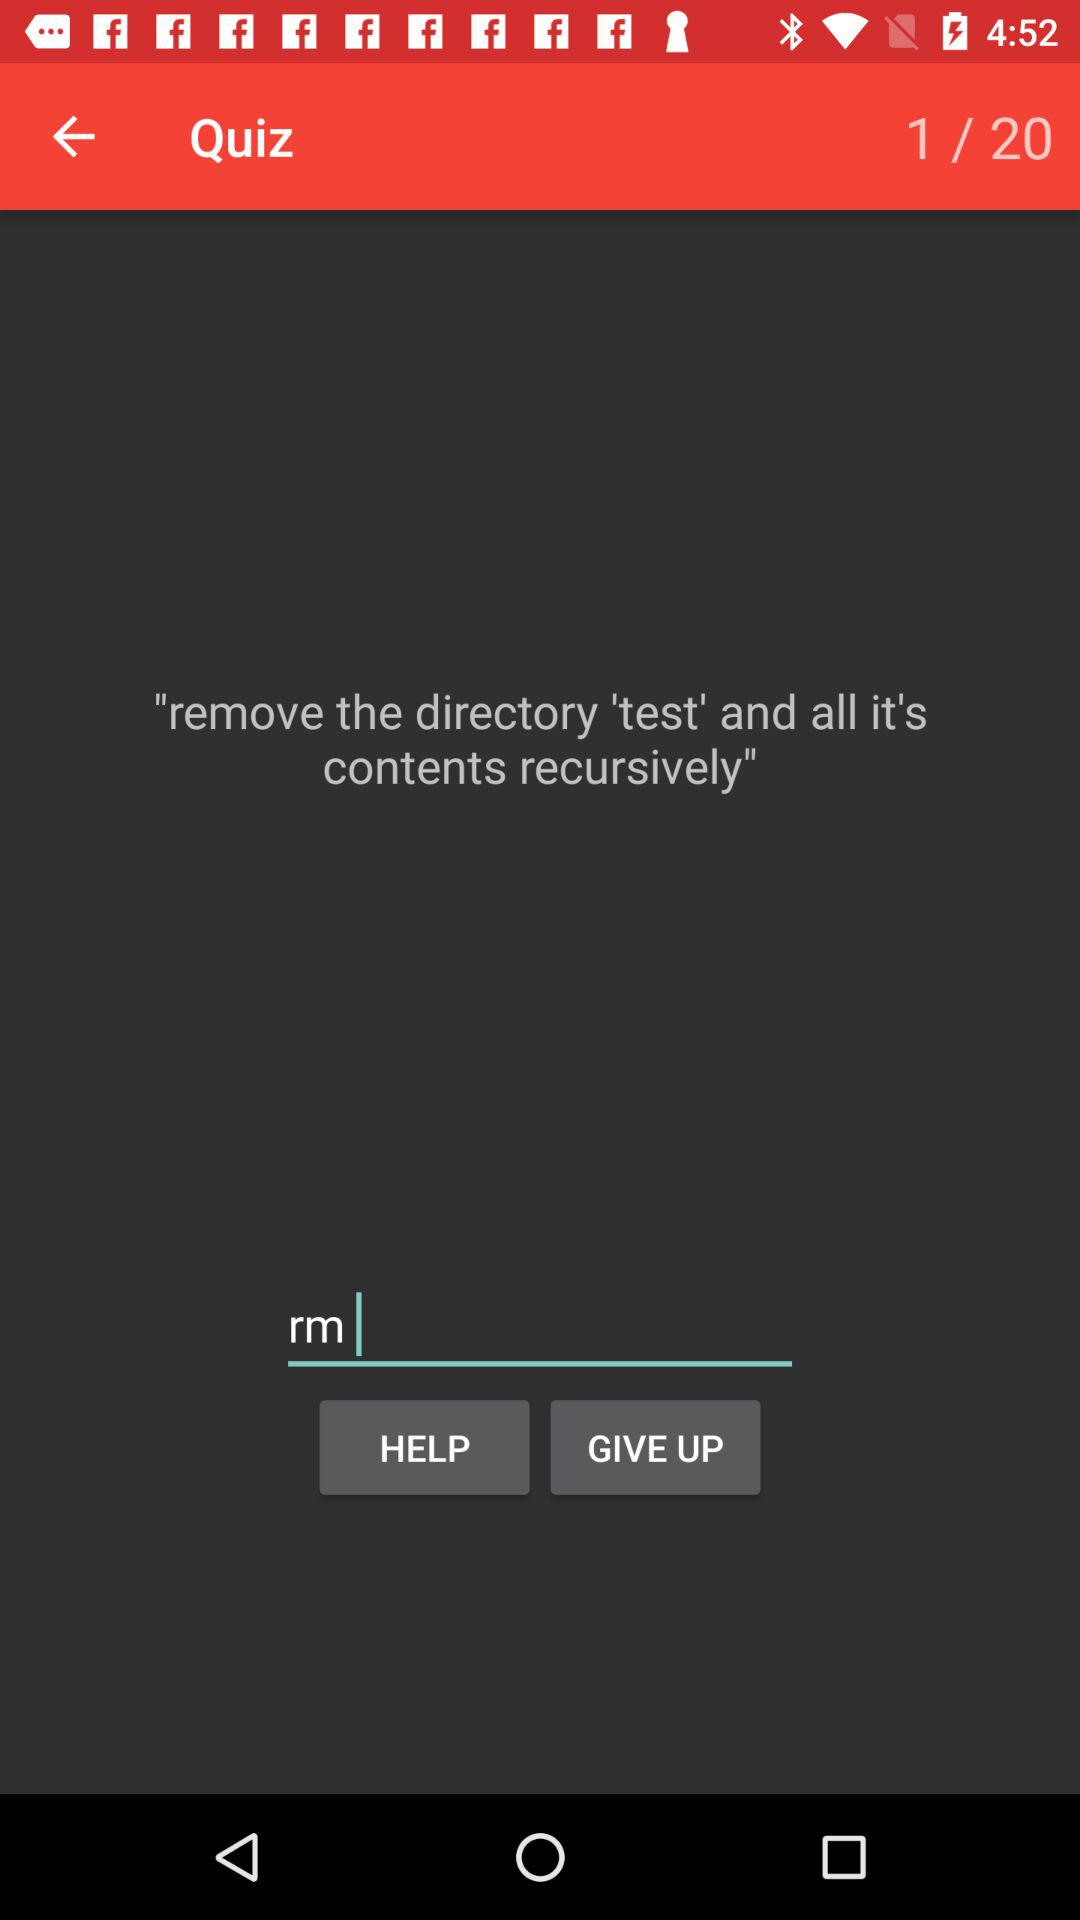What is the name of the directory? The name of the directory is "test". 